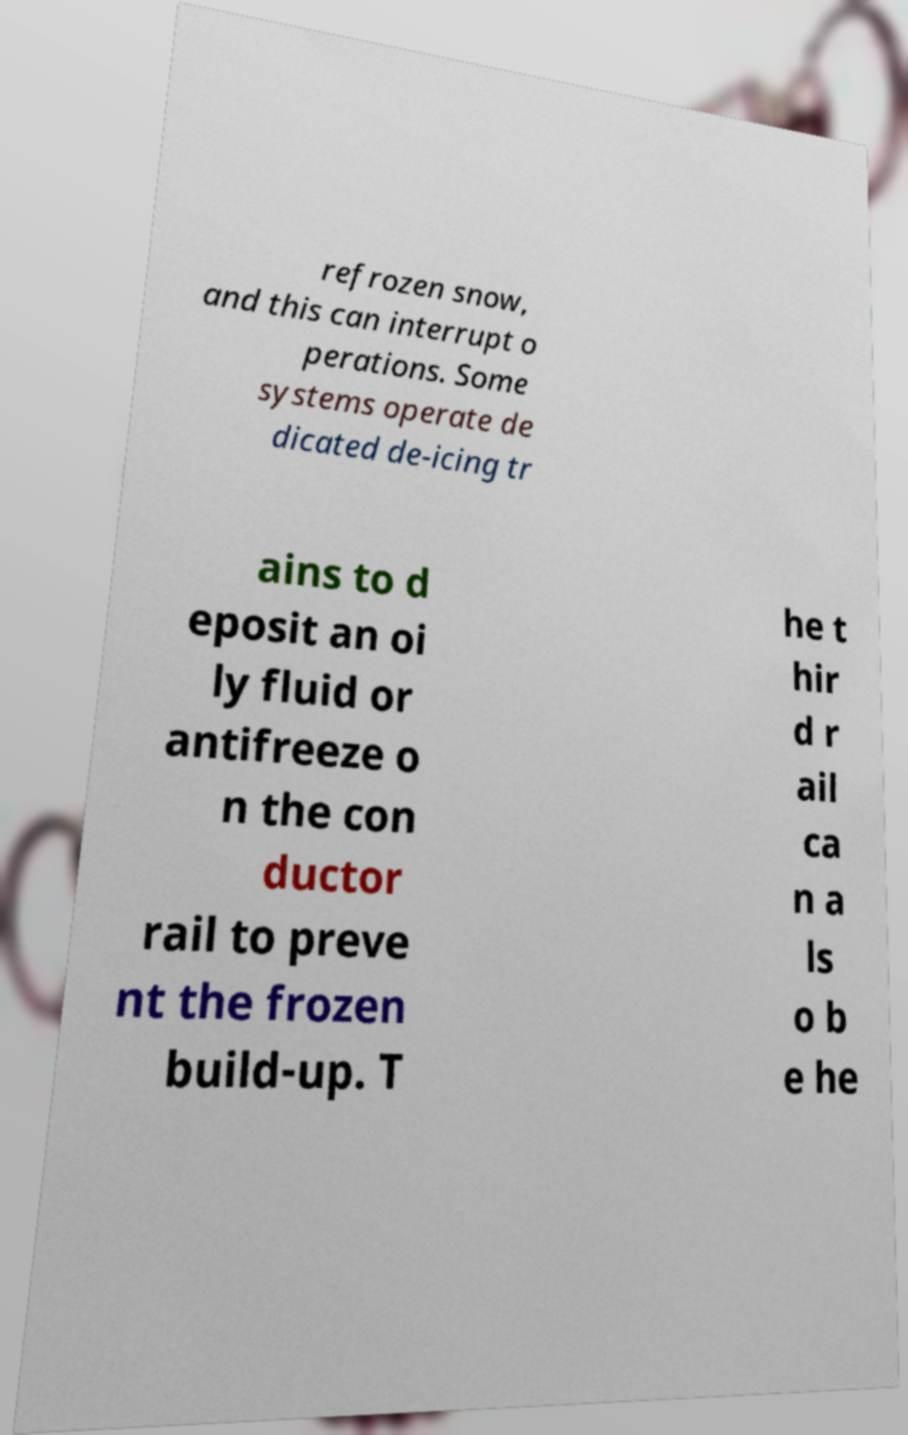Could you assist in decoding the text presented in this image and type it out clearly? refrozen snow, and this can interrupt o perations. Some systems operate de dicated de-icing tr ains to d eposit an oi ly fluid or antifreeze o n the con ductor rail to preve nt the frozen build-up. T he t hir d r ail ca n a ls o b e he 